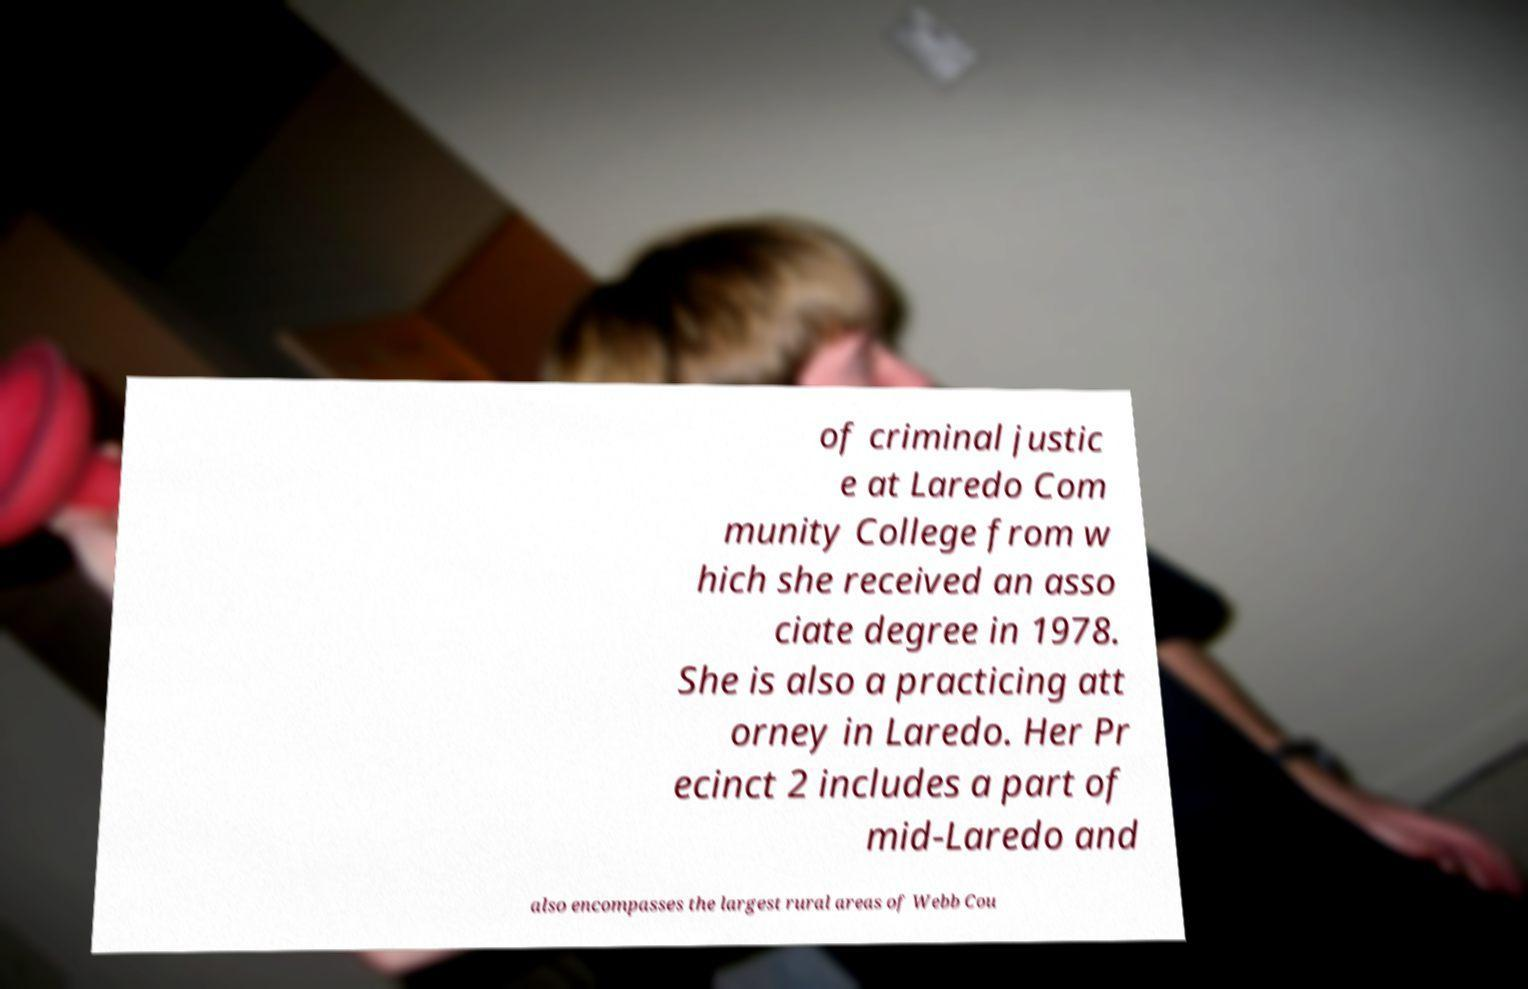Can you accurately transcribe the text from the provided image for me? of criminal justic e at Laredo Com munity College from w hich she received an asso ciate degree in 1978. She is also a practicing att orney in Laredo. Her Pr ecinct 2 includes a part of mid-Laredo and also encompasses the largest rural areas of Webb Cou 